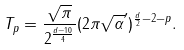<formula> <loc_0><loc_0><loc_500><loc_500>T _ { p } = \frac { \sqrt { \pi } } { 2 ^ { \frac { d - 1 0 } { 4 } } } ( 2 \pi \sqrt { \alpha } ^ { \prime } ) ^ { \frac { d } { 2 } - 2 - p } .</formula> 